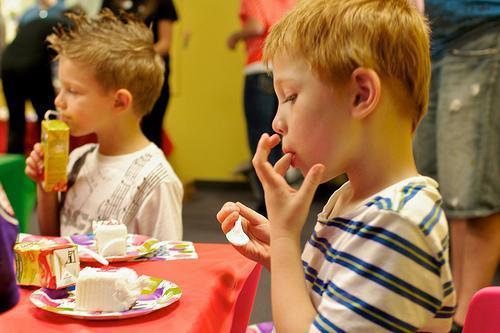How many boys are drinking from a juice box?
Give a very brief answer. 1. How many people are drinking juice?
Give a very brief answer. 1. 